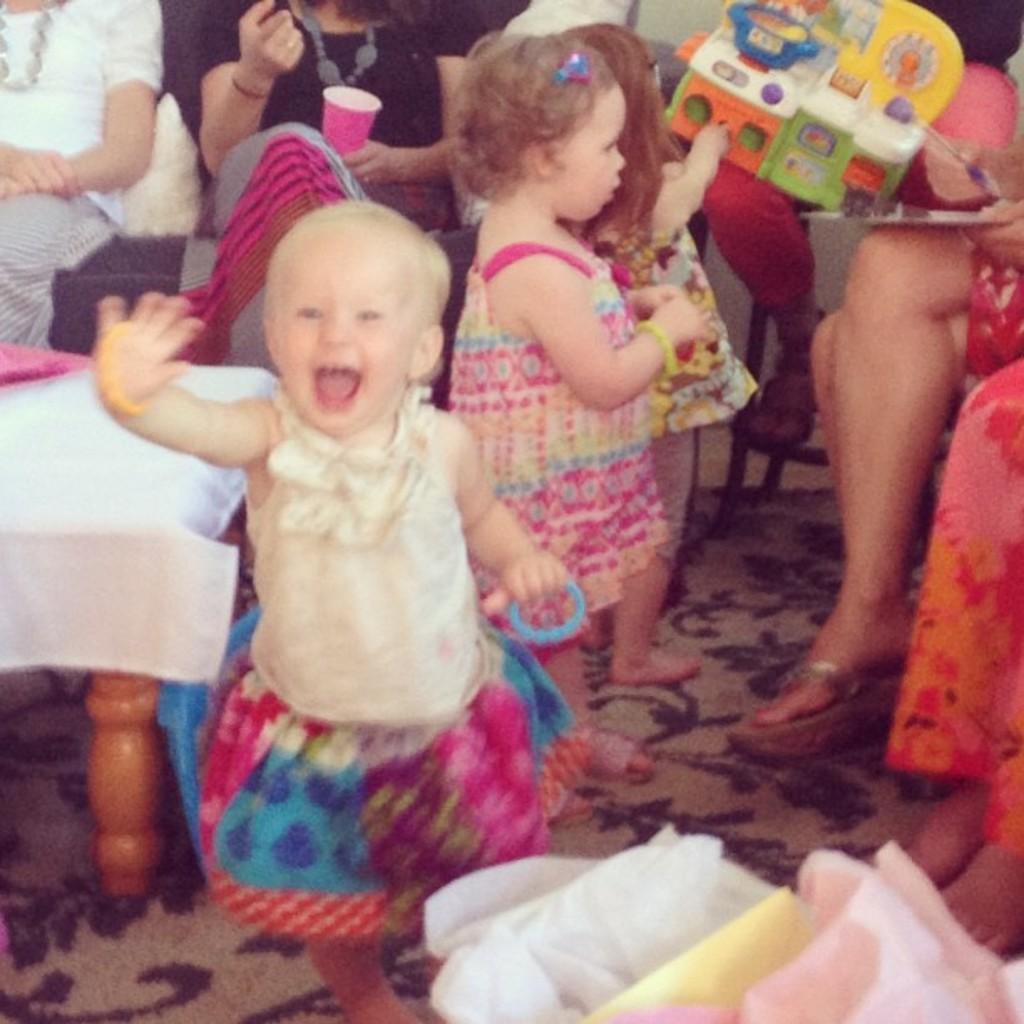Describe this image in one or two sentences. On the left side, there is a stool covered with white color cloth. Beside this stool, there are children standing on the floor, which is covered with a carpet. On the right side, there are persons sitting. In the background, there are persons sitting. 